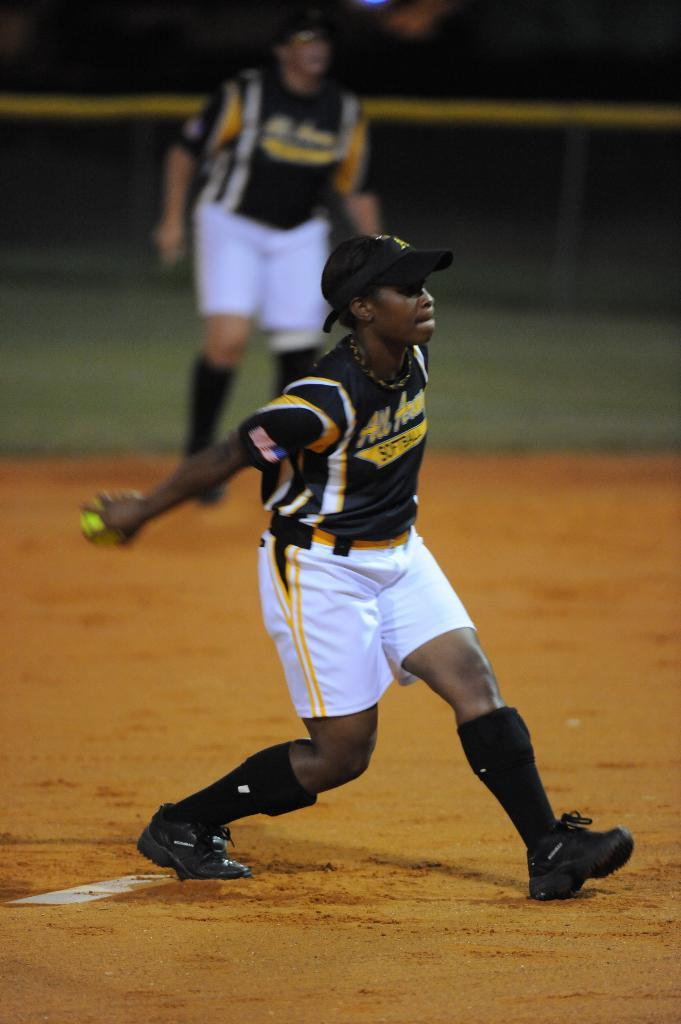<image>
Render a clear and concise summary of the photo. Athlete wearing a top that says "SOFTBALL" is pitching the ball. 